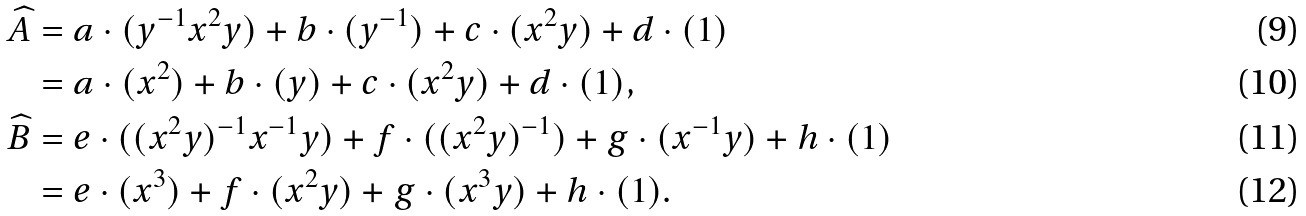Convert formula to latex. <formula><loc_0><loc_0><loc_500><loc_500>\widehat { A } & = a \cdot ( y ^ { - 1 } x ^ { 2 } y ) + b \cdot ( y ^ { - 1 } ) + c \cdot ( x ^ { 2 } y ) + d \cdot ( 1 ) \\ & = a \cdot ( x ^ { 2 } ) + b \cdot ( y ) + c \cdot ( x ^ { 2 } y ) + d \cdot ( 1 ) , \\ \widehat { B } & = e \cdot ( ( x ^ { 2 } y ) ^ { - 1 } x ^ { - 1 } y ) + f \cdot ( ( x ^ { 2 } y ) ^ { - 1 } ) + g \cdot ( x ^ { - 1 } y ) + h \cdot ( 1 ) \\ & = e \cdot ( x ^ { 3 } ) + f \cdot ( x ^ { 2 } y ) + g \cdot ( x ^ { 3 } y ) + h \cdot ( 1 ) .</formula> 